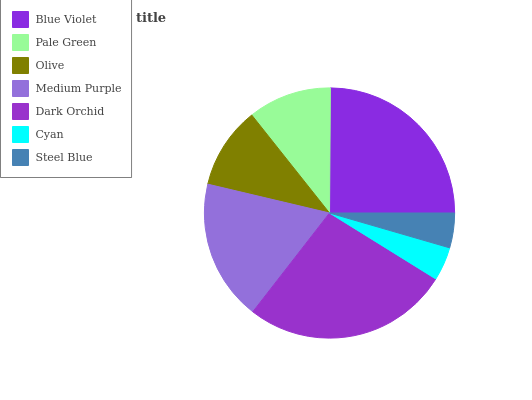Is Cyan the minimum?
Answer yes or no. Yes. Is Dark Orchid the maximum?
Answer yes or no. Yes. Is Pale Green the minimum?
Answer yes or no. No. Is Pale Green the maximum?
Answer yes or no. No. Is Blue Violet greater than Pale Green?
Answer yes or no. Yes. Is Pale Green less than Blue Violet?
Answer yes or no. Yes. Is Pale Green greater than Blue Violet?
Answer yes or no. No. Is Blue Violet less than Pale Green?
Answer yes or no. No. Is Pale Green the high median?
Answer yes or no. Yes. Is Pale Green the low median?
Answer yes or no. Yes. Is Cyan the high median?
Answer yes or no. No. Is Steel Blue the low median?
Answer yes or no. No. 